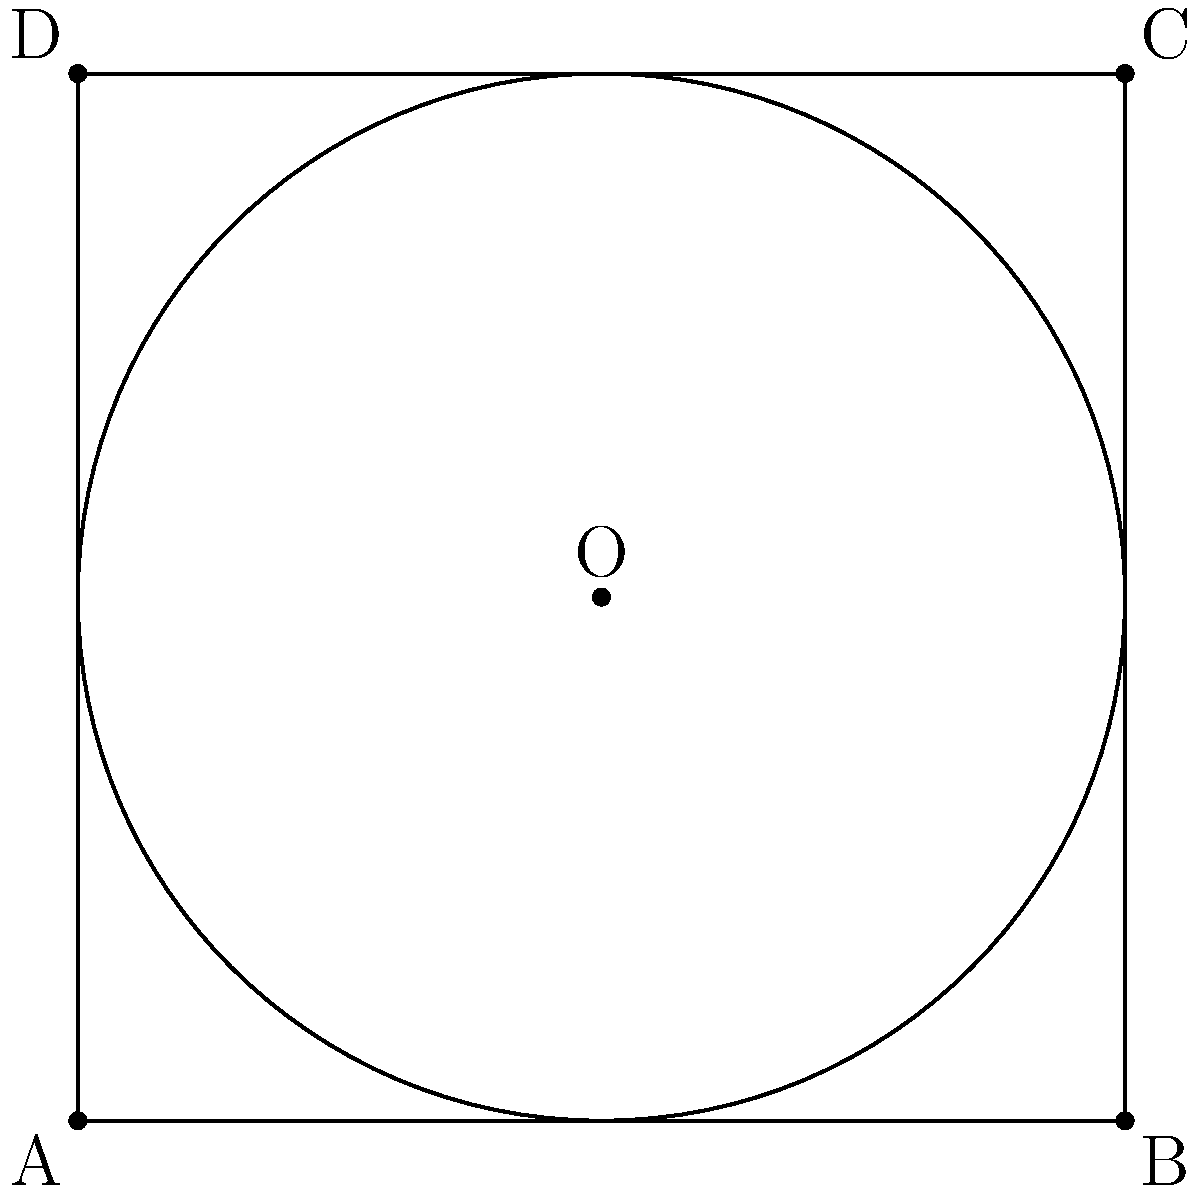In the context of optimizing driver algorithms for gaming peripherals, consider a square with side length $s$ and an inscribed circle. If the side length of the square is 4 units, what is the radius $r$ of the inscribed circle? Let's approach this step-by-step:

1) In a square with an inscribed circle, the diameter of the circle is equal to the side length of the square.

2) The radius is half of the diameter. So, we can express this relationship as:

   $$ 2r = s $$

3) We're given that the side length $s$ is 4 units. Let's substitute this into our equation:

   $$ 2r = 4 $$

4) Now, we can solve for $r$ by dividing both sides by 2:

   $$ r = \frac{4}{2} = 2 $$

5) Therefore, the radius of the inscribed circle is 2 units.

In the context of driver development, understanding geometric relationships like this can be crucial for optimizing algorithms that deal with cursor movement, especially in games that require precise circular motions or calculations involving circular areas on the screen.
Answer: $r = 2$ units 